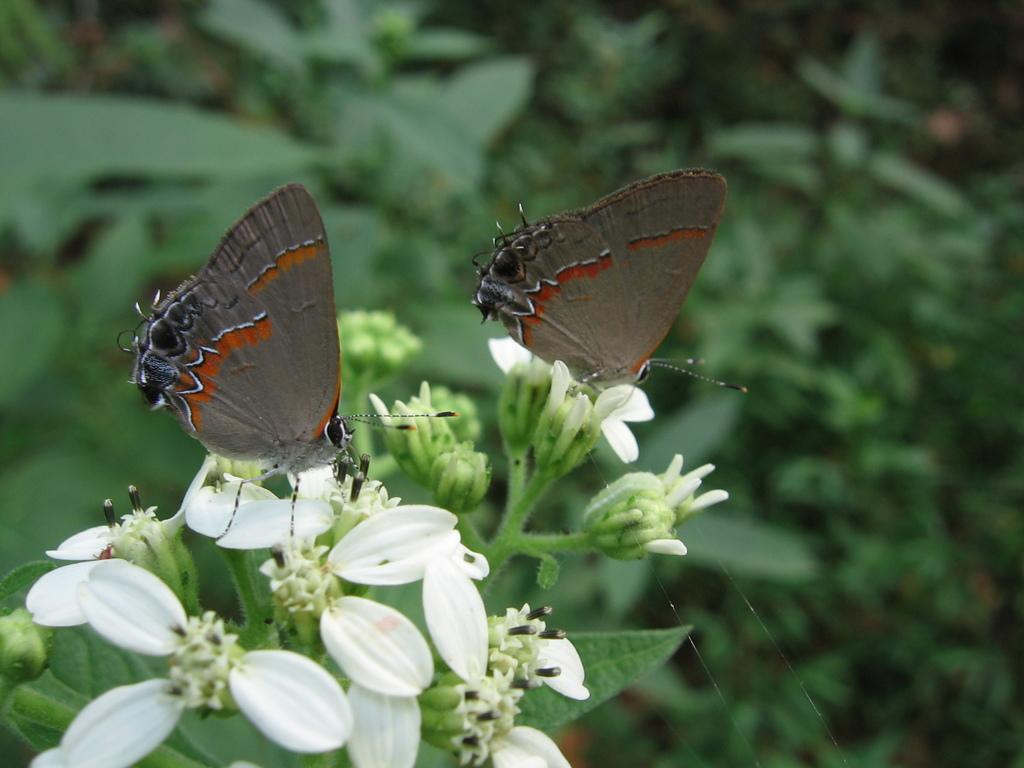What type of animals can be seen in the image? There are butterflies in the image. What are the butterflies resting on? The butterflies are on flowers. What can be seen in the background of the image? There are plants in the background of the image. What type of fruit is hanging from the clouds in the image? There are no clouds or fruit present in the image; it features butterflies on flowers with plants in the background. 